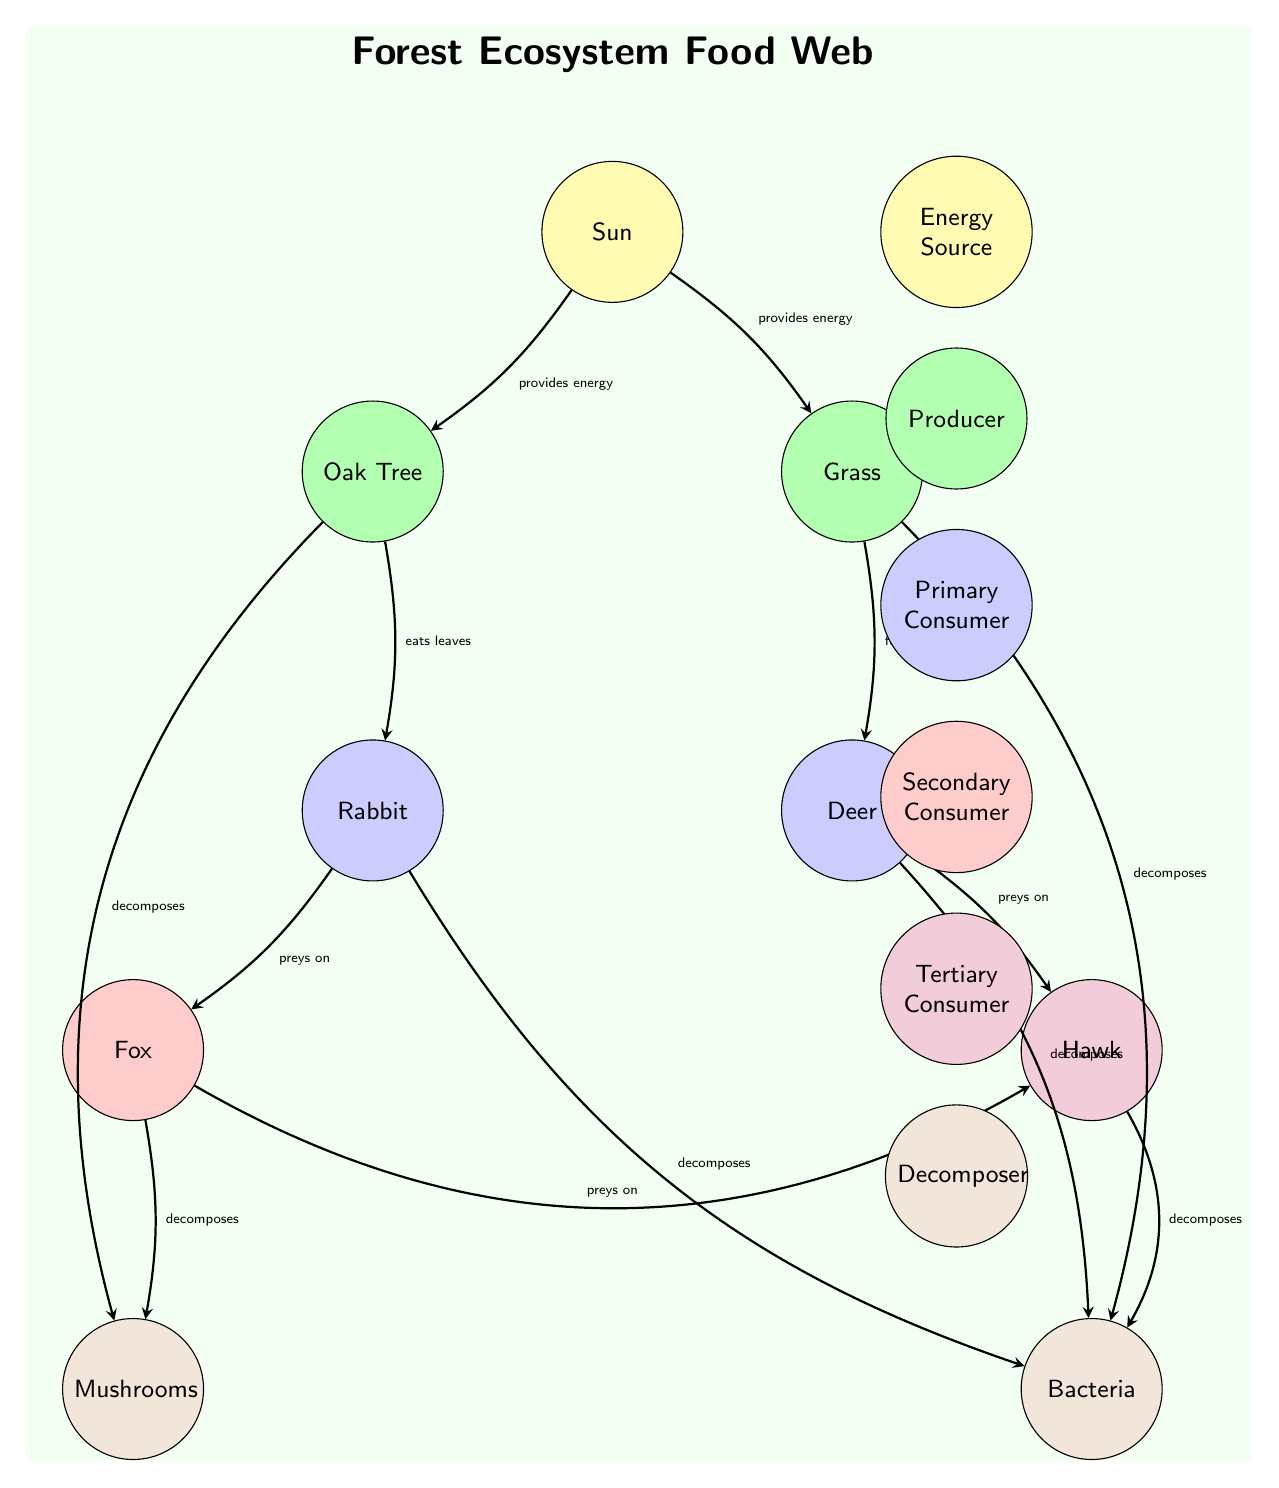What is the energy source in the food web? The diagram clearly indicates that the Sun is the energy source, as it is the initial node and all producers depend on it for energy.
Answer: Sun How many producers are present in the diagram? By examining the nodes labeled as producers, we can identify the Oak Tree and Grass, giving us a total of two producers in the diagram.
Answer: 2 Which consumer preys on the rabbit? The diagram indicates that the Fox is the primary consumer that preys on the Rabbit, as there is a directional edge from the Rabbit to the Fox.
Answer: Fox What role do mushrooms play in the food web? The diagram classifies Mushrooms as decomposers, which are responsible for breaking down organic matter, specifically illustrated as decomposing material from certain consumers and producers.
Answer: Decomposer How many total consumers are shown in the food web? Counting the consumers labeled in the diagram, we see that there is one primary consumer (Rabbit), one primary consumer (Deer), one secondary consumer (Fox), and one tertiary consumer (Hawk), resulting in a total of four consumers.
Answer: 4 Which two organisms can directly decompose the remains of the Hawk? The diagram shows that the Hawk's remains can be decomposed by either Bacteria or Mushrooms, as both are indicated as decomposers with edges linking them to the Hawk.
Answer: Bacteria, Mushrooms What relationship exists between the Deer and the Hawk? In the diagram, the relationship is that the Hawk preys on the Deer, shown by a directed edge indicating this predatory interaction.
Answer: Preys on Which producer is directly connected to the rabbit as its food source? The Rabbit is directly connected to the Oak Tree, as it eats the leaves of the Oak Tree, which is indicated by a directional edge pointing from the Oak Tree to the Rabbit in the diagram.
Answer: Oak Tree How does Grass receive energy in this ecosystem? The Grass, being a producer, receives energy directly from the Sun as depicted in the diagram through a directed edge that confirms this relationship of energy transfer.
Answer: Provides energy from Sun 